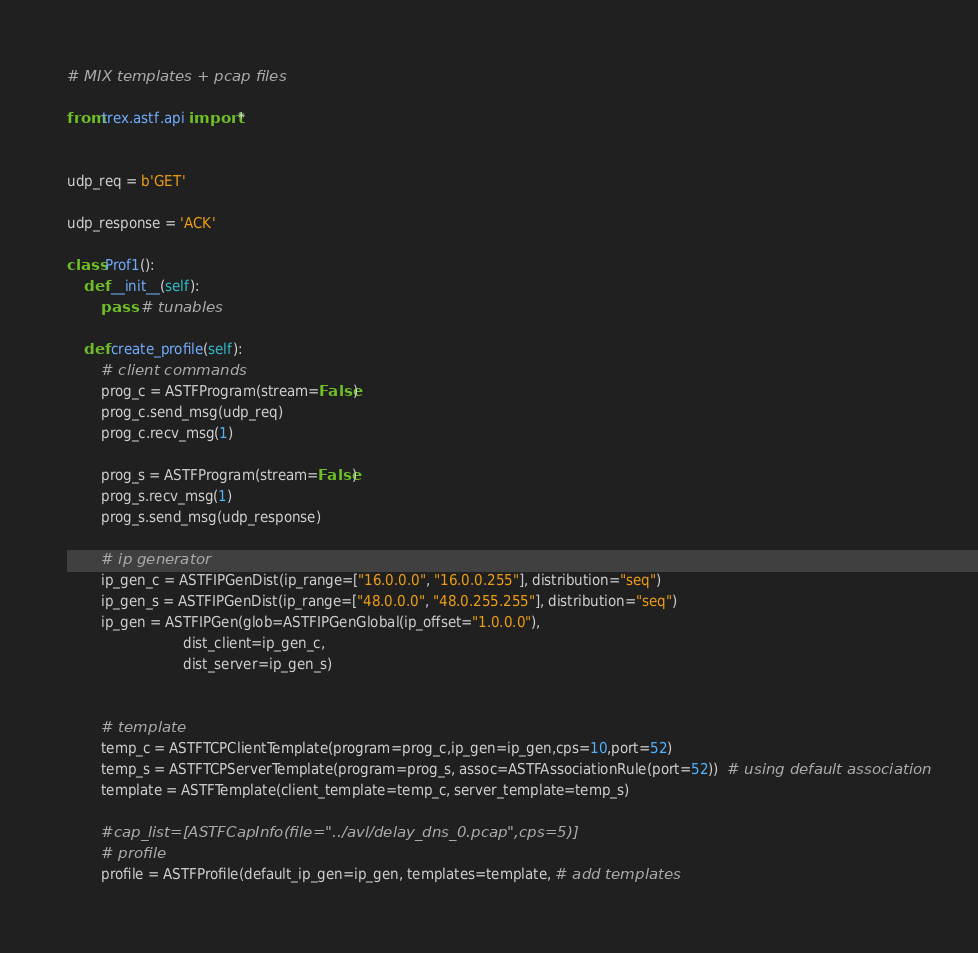<code> <loc_0><loc_0><loc_500><loc_500><_Python_># MIX templates + pcap files 

from trex.astf.api import *


udp_req = b'GET'

udp_response = 'ACK'

class Prof1():
    def __init__(self):
        pass  # tunables

    def create_profile(self):
        # client commands
        prog_c = ASTFProgram(stream=False)
        prog_c.send_msg(udp_req)
        prog_c.recv_msg(1)

        prog_s = ASTFProgram(stream=False)
        prog_s.recv_msg(1)
        prog_s.send_msg(udp_response)

        # ip generator
        ip_gen_c = ASTFIPGenDist(ip_range=["16.0.0.0", "16.0.0.255"], distribution="seq")
        ip_gen_s = ASTFIPGenDist(ip_range=["48.0.0.0", "48.0.255.255"], distribution="seq")
        ip_gen = ASTFIPGen(glob=ASTFIPGenGlobal(ip_offset="1.0.0.0"),
                           dist_client=ip_gen_c,
                           dist_server=ip_gen_s)


        # template
        temp_c = ASTFTCPClientTemplate(program=prog_c,ip_gen=ip_gen,cps=10,port=52)
        temp_s = ASTFTCPServerTemplate(program=prog_s, assoc=ASTFAssociationRule(port=52))  # using default association
        template = ASTFTemplate(client_template=temp_c, server_template=temp_s)

        #cap_list=[ASTFCapInfo(file="../avl/delay_dns_0.pcap",cps=5)]
        # profile
        profile = ASTFProfile(default_ip_gen=ip_gen, templates=template, # add templates </code> 